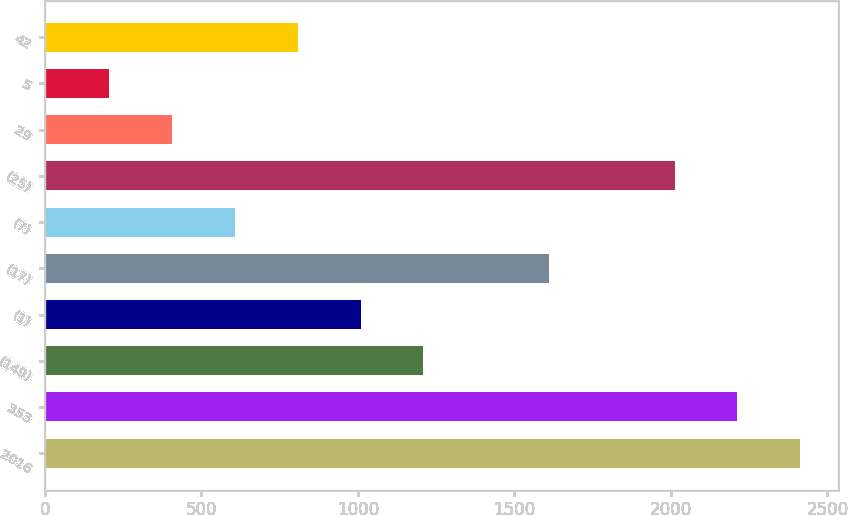Convert chart. <chart><loc_0><loc_0><loc_500><loc_500><bar_chart><fcel>2016<fcel>353<fcel>(149)<fcel>(1)<fcel>(17)<fcel>(7)<fcel>(25)<fcel>29<fcel>5<fcel>42<nl><fcel>2413.24<fcel>2212.62<fcel>1209.52<fcel>1008.9<fcel>1610.76<fcel>607.66<fcel>2012<fcel>407.04<fcel>206.42<fcel>808.28<nl></chart> 